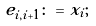<formula> <loc_0><loc_0><loc_500><loc_500>& e _ { i , i + 1 } \colon = x _ { i } ; &</formula> 